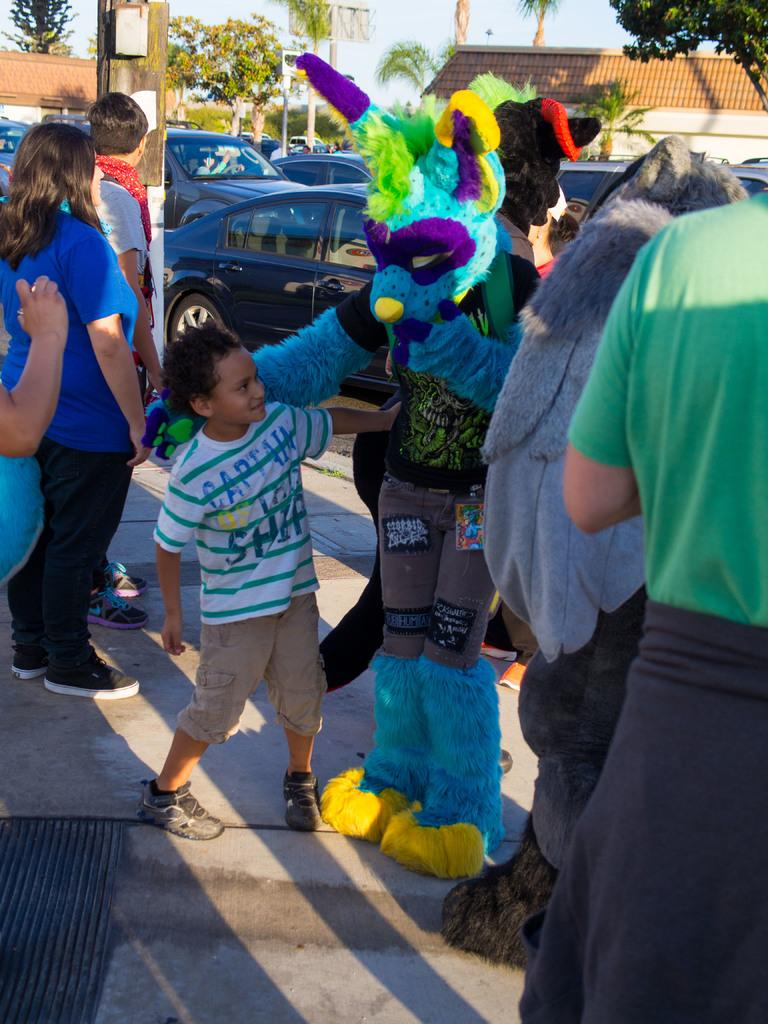What is happening in the image? There are people standing in the image. Can you describe the clothing of some of the people? Two people are wearing colorful costumes. What can be seen in the background of the image? Cars, trees, poles, and houses are visible in the background. What is the color of the sky in the image? The sky appears to be white in color. What type of yarn is being used by the ant in the image? There is no ant or yarn present in the image. 